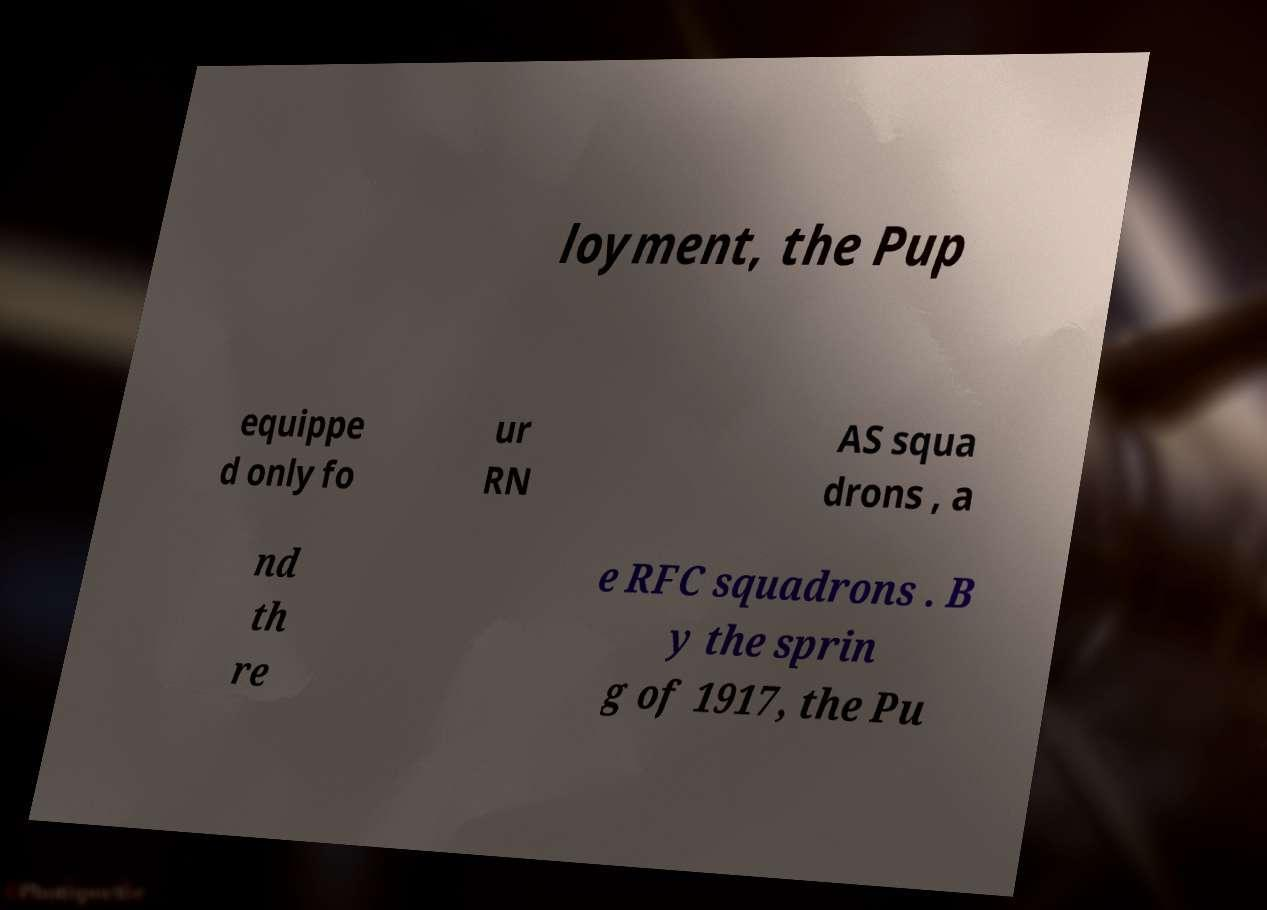Can you read and provide the text displayed in the image?This photo seems to have some interesting text. Can you extract and type it out for me? loyment, the Pup equippe d only fo ur RN AS squa drons , a nd th re e RFC squadrons . B y the sprin g of 1917, the Pu 